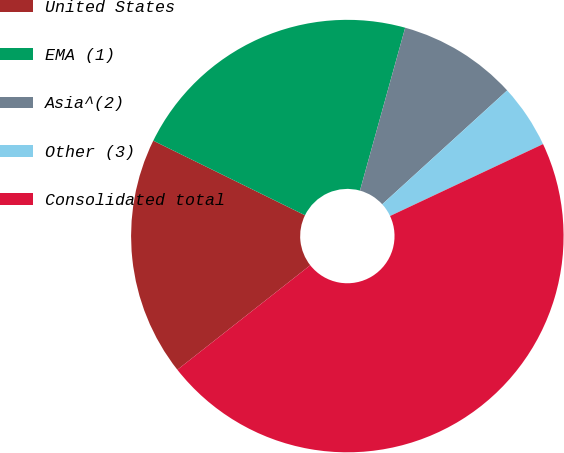Convert chart. <chart><loc_0><loc_0><loc_500><loc_500><pie_chart><fcel>United States<fcel>EMA (1)<fcel>Asia^(2)<fcel>Other (3)<fcel>Consolidated total<nl><fcel>17.88%<fcel>22.04%<fcel>8.93%<fcel>4.77%<fcel>46.39%<nl></chart> 